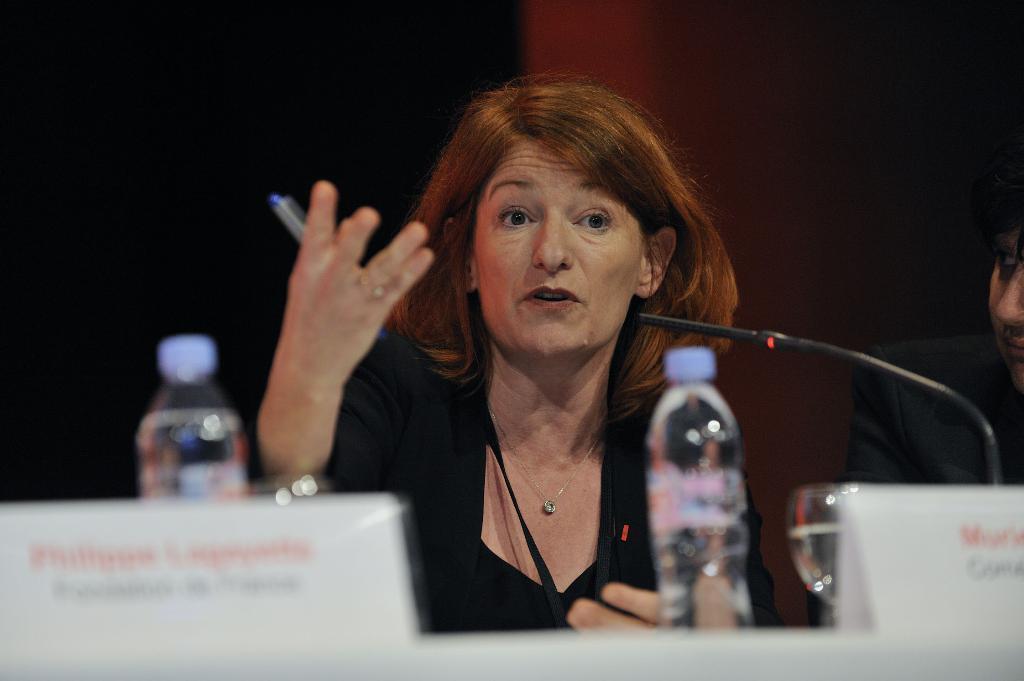How would you summarize this image in a sentence or two? In this picture I can see there is a woman sitting and speaking and there is a table in front of her and there is a water bottle on the table. 